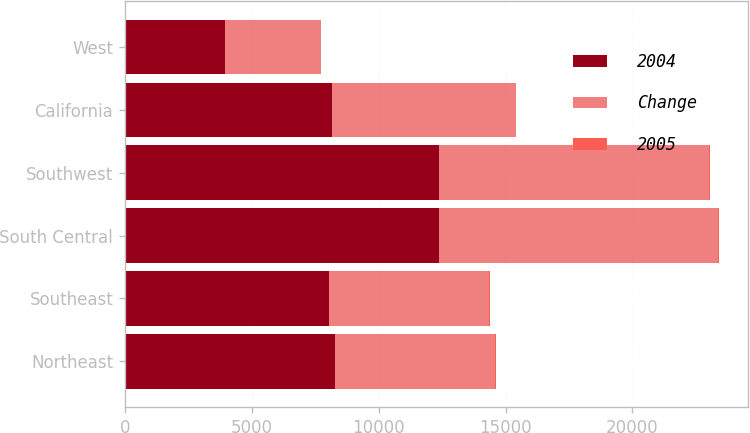<chart> <loc_0><loc_0><loc_500><loc_500><stacked_bar_chart><ecel><fcel>Northeast<fcel>Southeast<fcel>South Central<fcel>Southwest<fcel>California<fcel>West<nl><fcel>2004<fcel>8296<fcel>8050<fcel>12391<fcel>12391<fcel>8171<fcel>3933<nl><fcel>Change<fcel>6300<fcel>6294<fcel>10997<fcel>10632<fcel>7248<fcel>3792<nl><fcel>2005<fcel>32<fcel>28<fcel>13<fcel>17<fcel>13<fcel>4<nl></chart> 